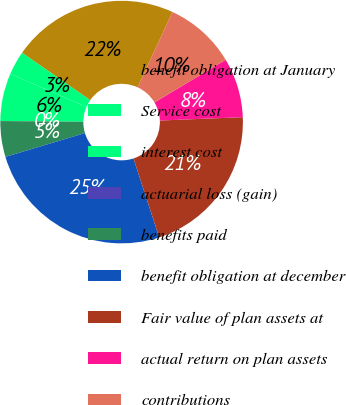Convert chart. <chart><loc_0><loc_0><loc_500><loc_500><pie_chart><fcel>benefit obligation at January<fcel>Service cost<fcel>interest cost<fcel>actuarial loss (gain)<fcel>benefits paid<fcel>benefit obligation at december<fcel>Fair value of plan assets at<fcel>actual return on plan assets<fcel>contributions<nl><fcel>22.21%<fcel>3.18%<fcel>6.35%<fcel>0.01%<fcel>4.77%<fcel>25.38%<fcel>20.63%<fcel>7.94%<fcel>9.53%<nl></chart> 